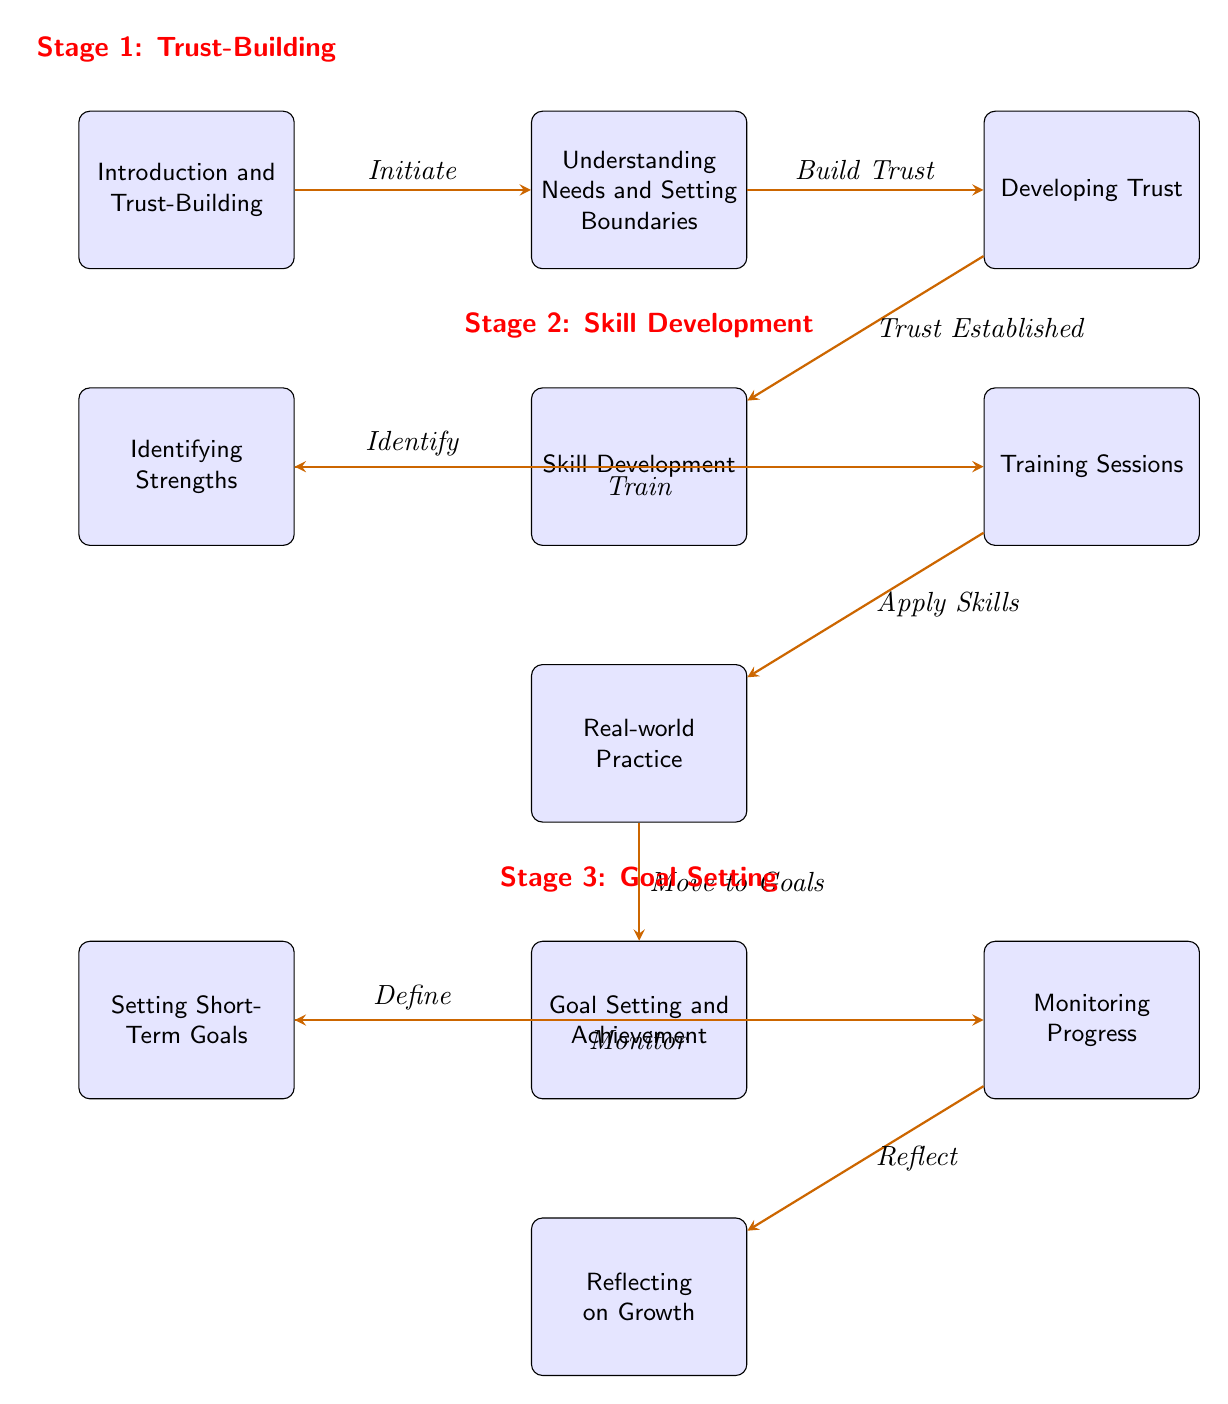What is the first stage in the mentoring relationship? The first stage is labeled as "Trust-Building" at the top of the diagram and is positioned directly above the initial node.
Answer: Trust-Building How many nodes are in the second stage? The second stage is centered around "Skill Development," which has three nodes connected to it: "Identifying Strengths," "Training Sessions," and "Real-world Practice." Counting these gives a total of three nodes.
Answer: 3 What is the last action before "Reflecting on Growth"? The arrow leading into "Reflecting on Growth" points from "Monitoring Progress," indicating that monitoring progress occurs right before reflecting on growth.
Answer: Monitoring Progress What is the relationship between "Understanding Needs and Setting Boundaries" and "Developing Trust"? "Understanding Needs and Setting Boundaries" flows directly into "Developing Trust," meaning that the understanding of needs and boundaries builds towards developing trust in the relationship.
Answer: Build Trust What stage follows "Skill Development"? The stage that follows "Skill Development" is labeled "Goal Setting and Achievement," which is positioned directly below the node for skill development in the diagram.
Answer: Goal Setting and Achievement How many actions lead into the "Goal Setting and Achievement" stage? The "Goal Setting and Achievement" node has three preceding actions leading into it: "Real-world Practice," "Setting Short-Term Goals," and "Monitoring Progress." Counting these gives a total of three actions leading into this stage.
Answer: 3 What does the node "Identifying Strengths" directly lead to? "Identifying Strengths" is indicated to flow directly into "Training Sessions," illustrating that identifying strengths is a precursor to the training process.
Answer: Training Sessions What type of diagram is this? This diagram is a "Textbook Diagram," based on its structure and the way it outlines the stages and flows of a mentoring relationship.
Answer: Textbook Diagram 